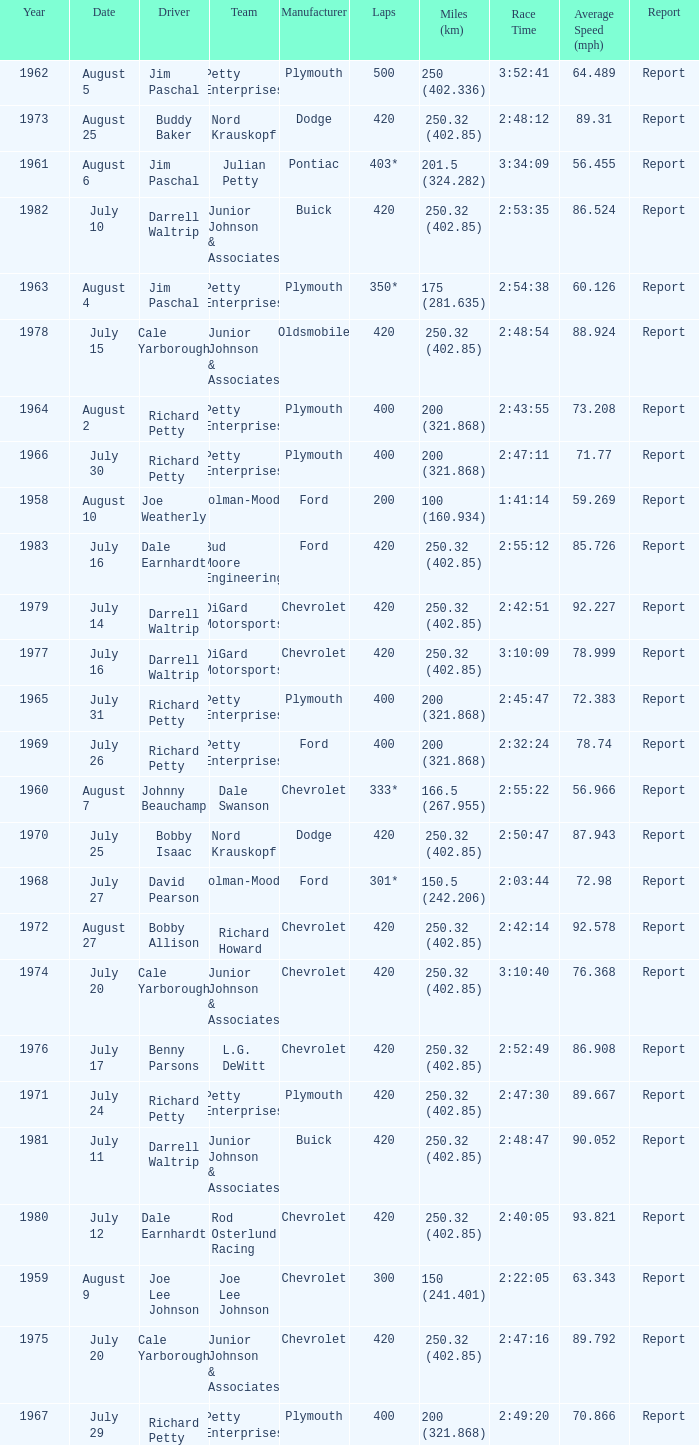How many races did Cale Yarborough win at an average speed of 88.924 mph? 1.0. 